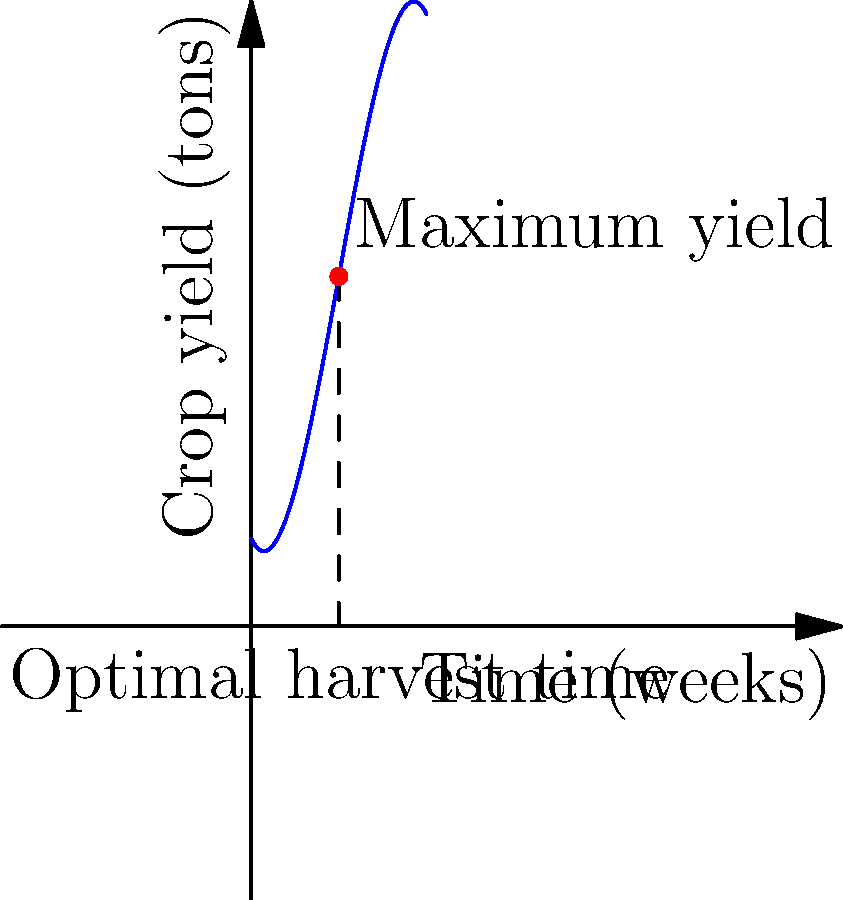As a farmers' market coordinator, you're advising local farmers on optimal harvest times. A particular crop's yield (in tons) over time (in weeks) is modeled by the function:

$$f(t) = -0.1t^3 + 1.5t^2 - 2t + 5$$

where $t$ is the time in weeks after planting. At what time should the farmers harvest this crop to maximize their yield? Round your answer to the nearest week. To find the optimal harvest time, we need to find the maximum of the given function. This occurs where the derivative of the function equals zero.

1) First, let's find the derivative of $f(t)$:
   $$f'(t) = -0.3t^2 + 3t - 2$$

2) Now, set $f'(t) = 0$ and solve for $t$:
   $$-0.3t^2 + 3t - 2 = 0$$

3) This is a quadratic equation. We can solve it using the quadratic formula:
   $$t = \frac{-b \pm \sqrt{b^2 - 4ac}}{2a}$$
   where $a = -0.3$, $b = 3$, and $c = -2$

4) Plugging in these values:
   $$t = \frac{-3 \pm \sqrt{3^2 - 4(-0.3)(-2)}}{2(-0.3)}$$
   $$= \frac{-3 \pm \sqrt{9 - 2.4}}{-0.6}$$
   $$= \frac{-3 \pm \sqrt{6.6}}{-0.6}$$

5) Solving this gives us two solutions:
   $t \approx 5.13$ or $t \approx 4.87$

6) Since we're looking for a maximum, and the leading coefficient of our original function is negative (indicating it opens downward), the larger value will give us the maximum.

7) Rounding to the nearest week, we get 5 weeks.

Therefore, farmers should harvest the crop approximately 5 weeks after planting to maximize their yield.
Answer: 5 weeks 